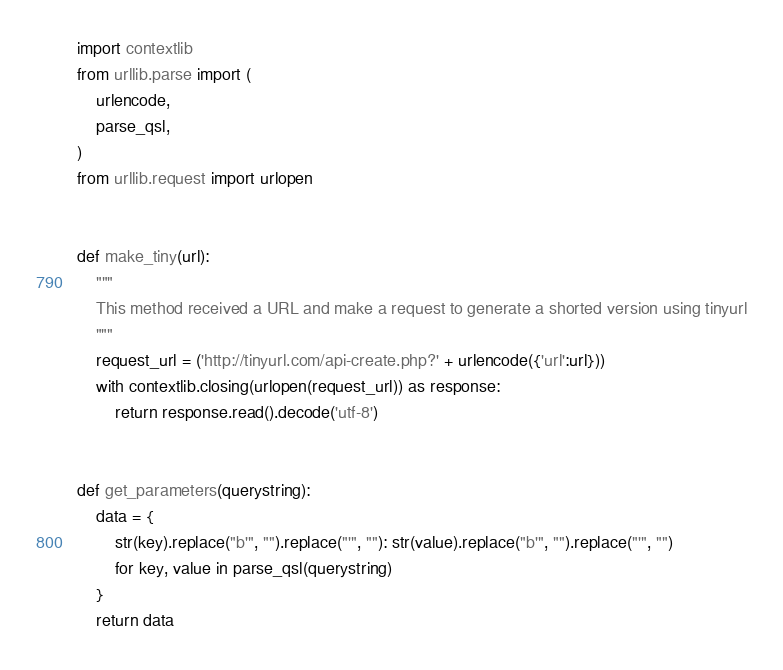<code> <loc_0><loc_0><loc_500><loc_500><_Python_>import contextlib
from urllib.parse import (
    urlencode,
    parse_qsl,
)
from urllib.request import urlopen


def make_tiny(url):
    """
    This method received a URL and make a request to generate a shorted version using tinyurl
    """
    request_url = ('http://tinyurl.com/api-create.php?' + urlencode({'url':url}))
    with contextlib.closing(urlopen(request_url)) as response:
        return response.read().decode('utf-8')


def get_parameters(querystring):
    data = {
        str(key).replace("b'", "").replace("'", ""): str(value).replace("b'", "").replace("'", "")
        for key, value in parse_qsl(querystring)
    }
    return data</code> 